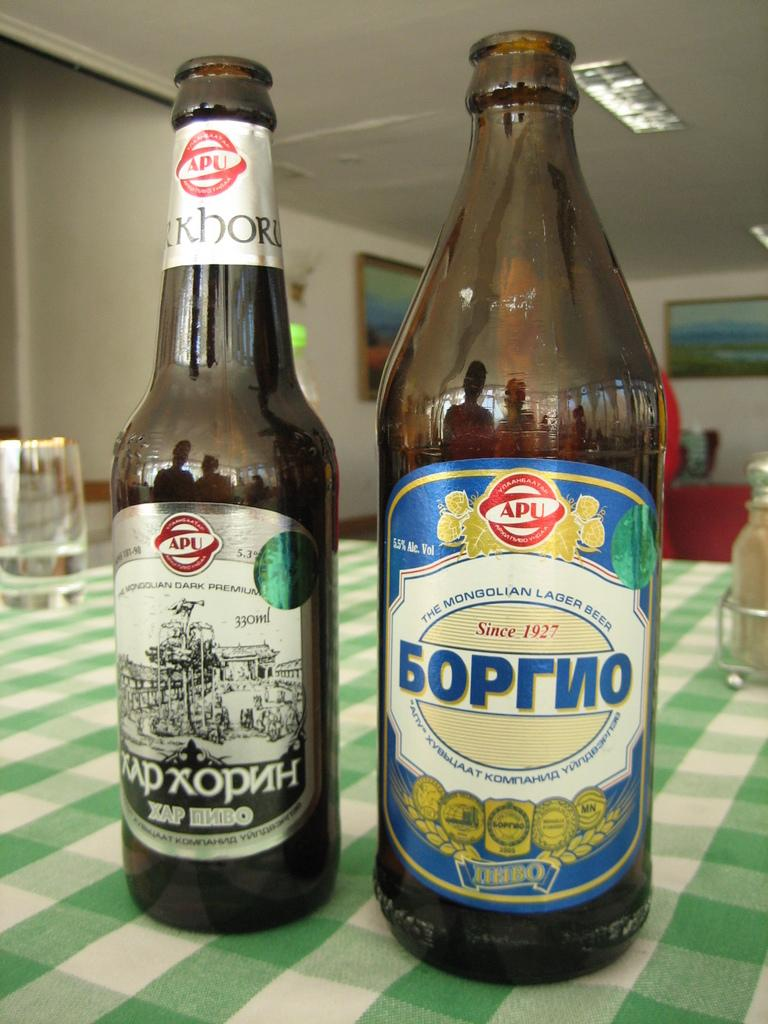<image>
Give a short and clear explanation of the subsequent image. A couple of Russian beers have the APU label on them. 